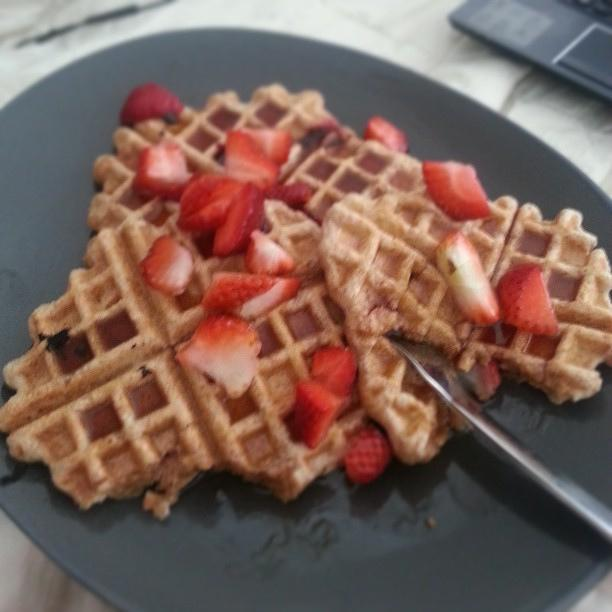What is most likely to be added to this food item? Please explain your reasoning. syrup. Waffles use syrup. 